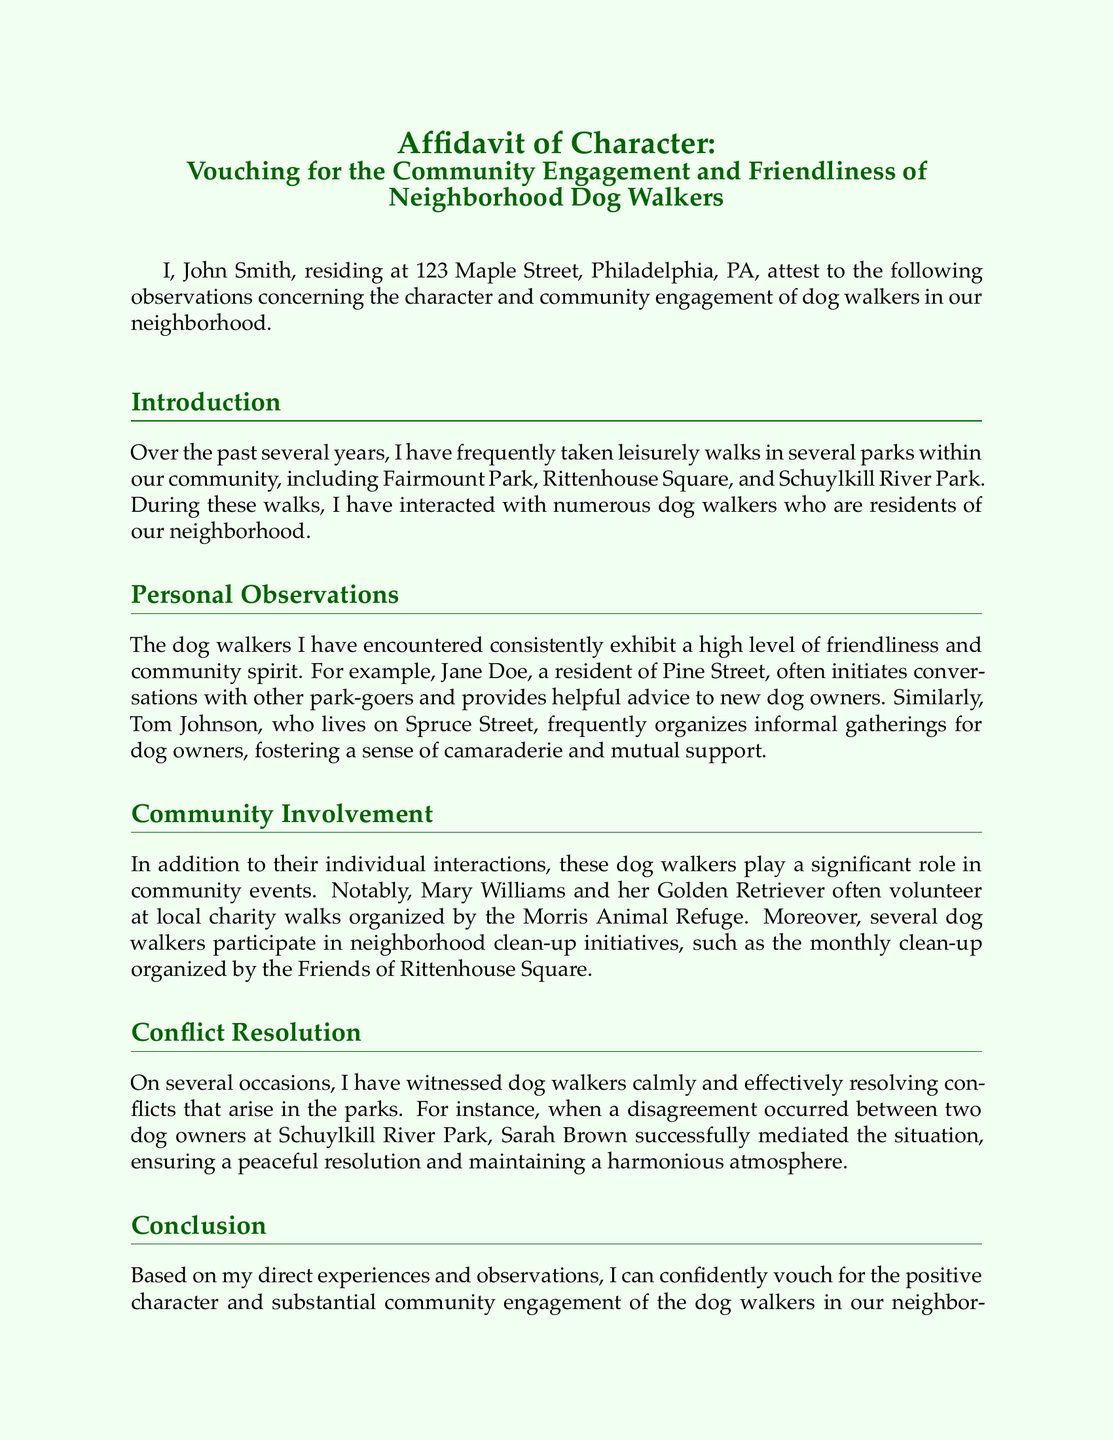What is the name of the affiant? The name of the affiant is mentioned at the beginning of the document.
Answer: John Smith What is the address of the affiant? The address of the affiant is provided in the introductory section of the document.
Answer: 123 Maple Street, Philadelphia, PA What is the date of notarization? The notarization date is listed towards the end of the affidavit.
Answer: 10th day of October, 2023 Which park is mentioned in relation to community engagement? The document lists several parks where interactions occurred, focusing on community engagement.
Answer: Schuylkill River Park Who organized informal gatherings for dog owners? This person's contributions to fostering community are highlighted within the document.
Answer: Tom Johnson What type of events do dog walkers participate in? The affidavit refers to specific types of events that community members engage in.
Answer: Local charity walks Who is noted for resolving conflicts at the park? The document highlights a specific individual known for their conflict resolution abilities.
Answer: Sarah Brown What breed of dog is mentioned in relation to Mary Williams? The specific breed of dog is mentioned to identify Mary Williams in the context of community engagement.
Answer: Golden Retriever What is the name of the Notary Public? This information is included at the end of the document, per affidavit protocols.
Answer: Kelly Thomas 